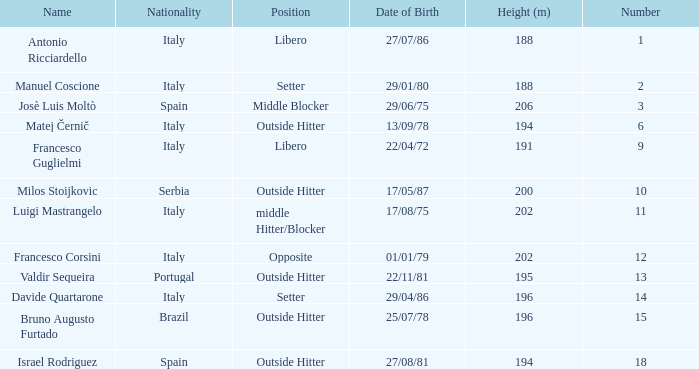Name the height for date of birth being 17/08/75 202.0. 